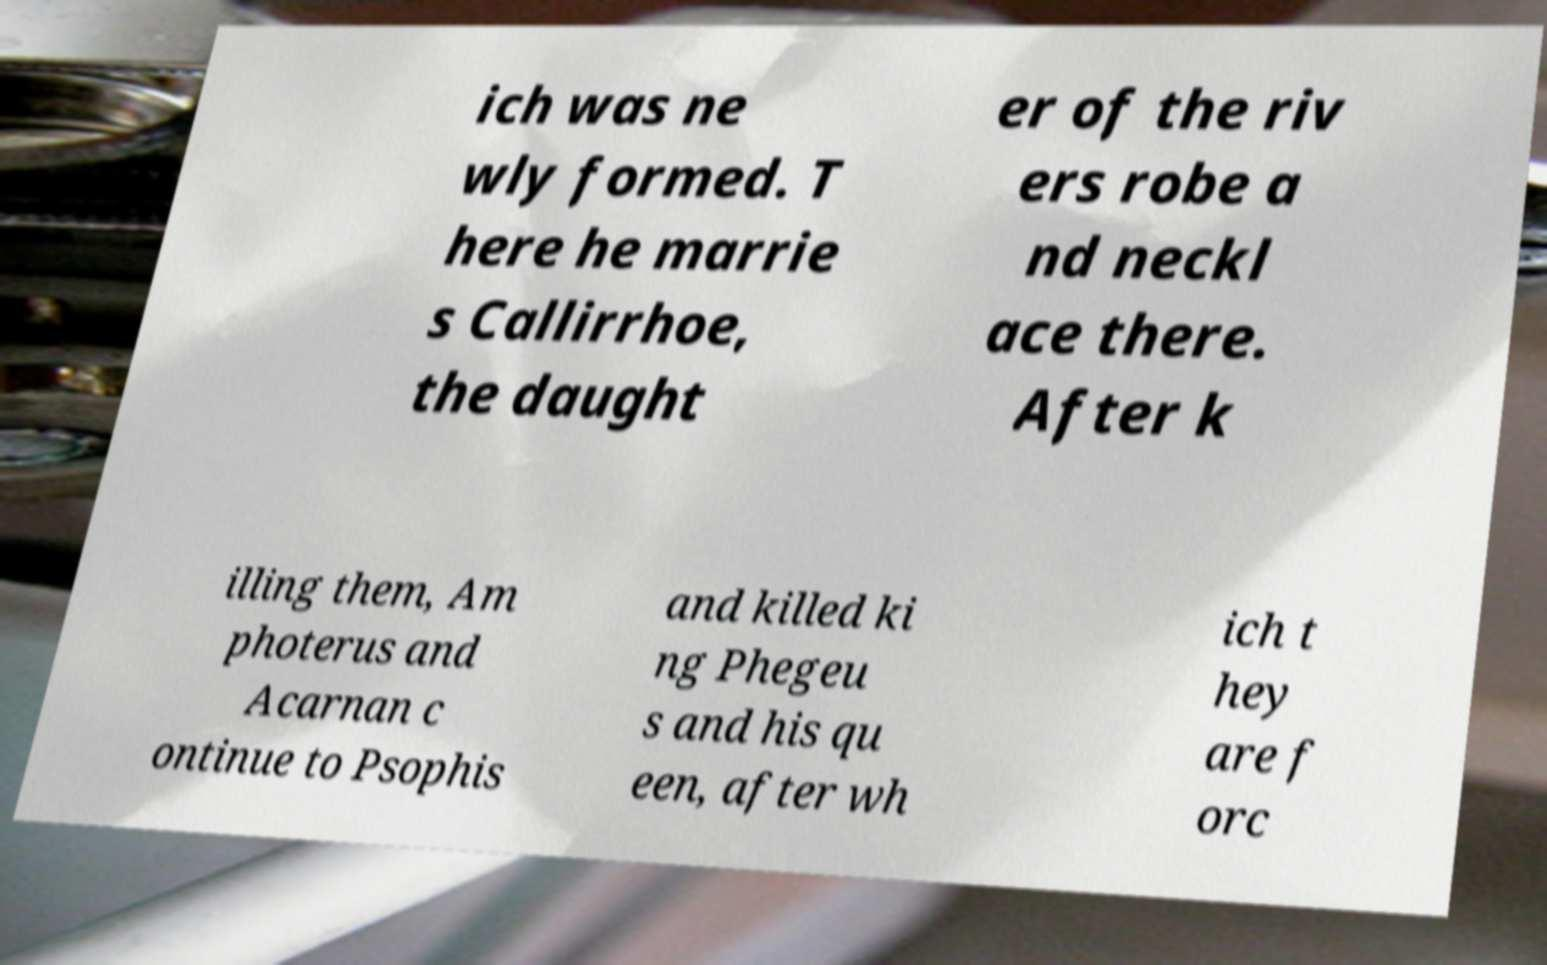For documentation purposes, I need the text within this image transcribed. Could you provide that? ich was ne wly formed. T here he marrie s Callirrhoe, the daught er of the riv ers robe a nd neckl ace there. After k illing them, Am photerus and Acarnan c ontinue to Psophis and killed ki ng Phegeu s and his qu een, after wh ich t hey are f orc 